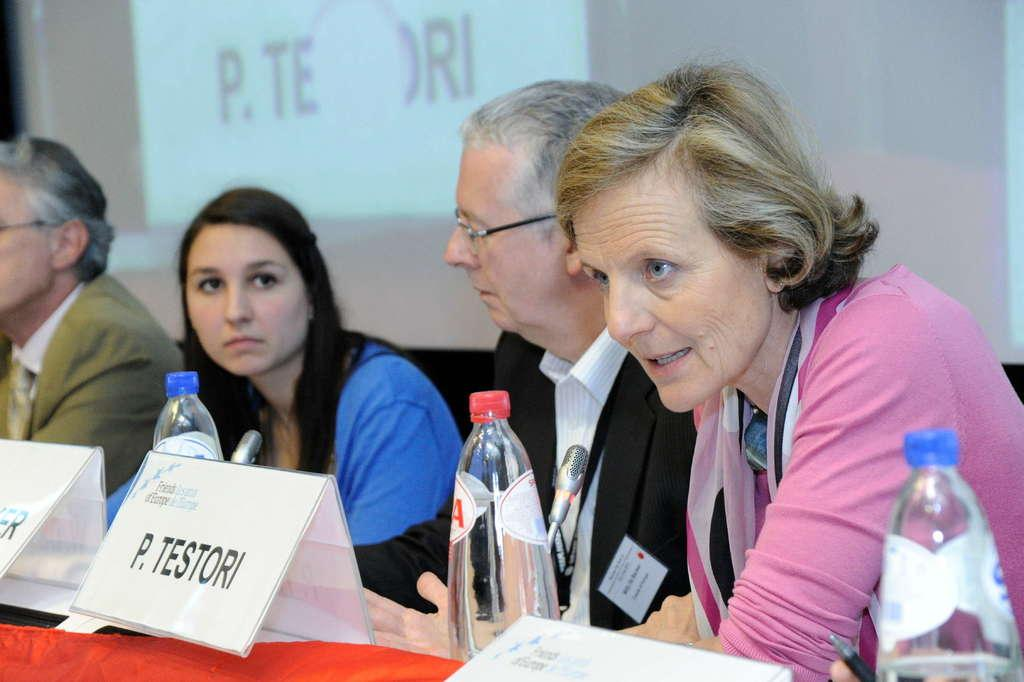What are the people doing in the image? The people are standing on a chair. What objects can be seen on the table in the image? There are water bottles on a table. What type of fog can be seen surrounding the people in the image? There is no fog present in the image; it only shows people standing on a chair and water bottles on a table. What kind of silk material is draped over the water bottles in the image? There is no silk material present in the image; the water bottles are simply placed on the table. 